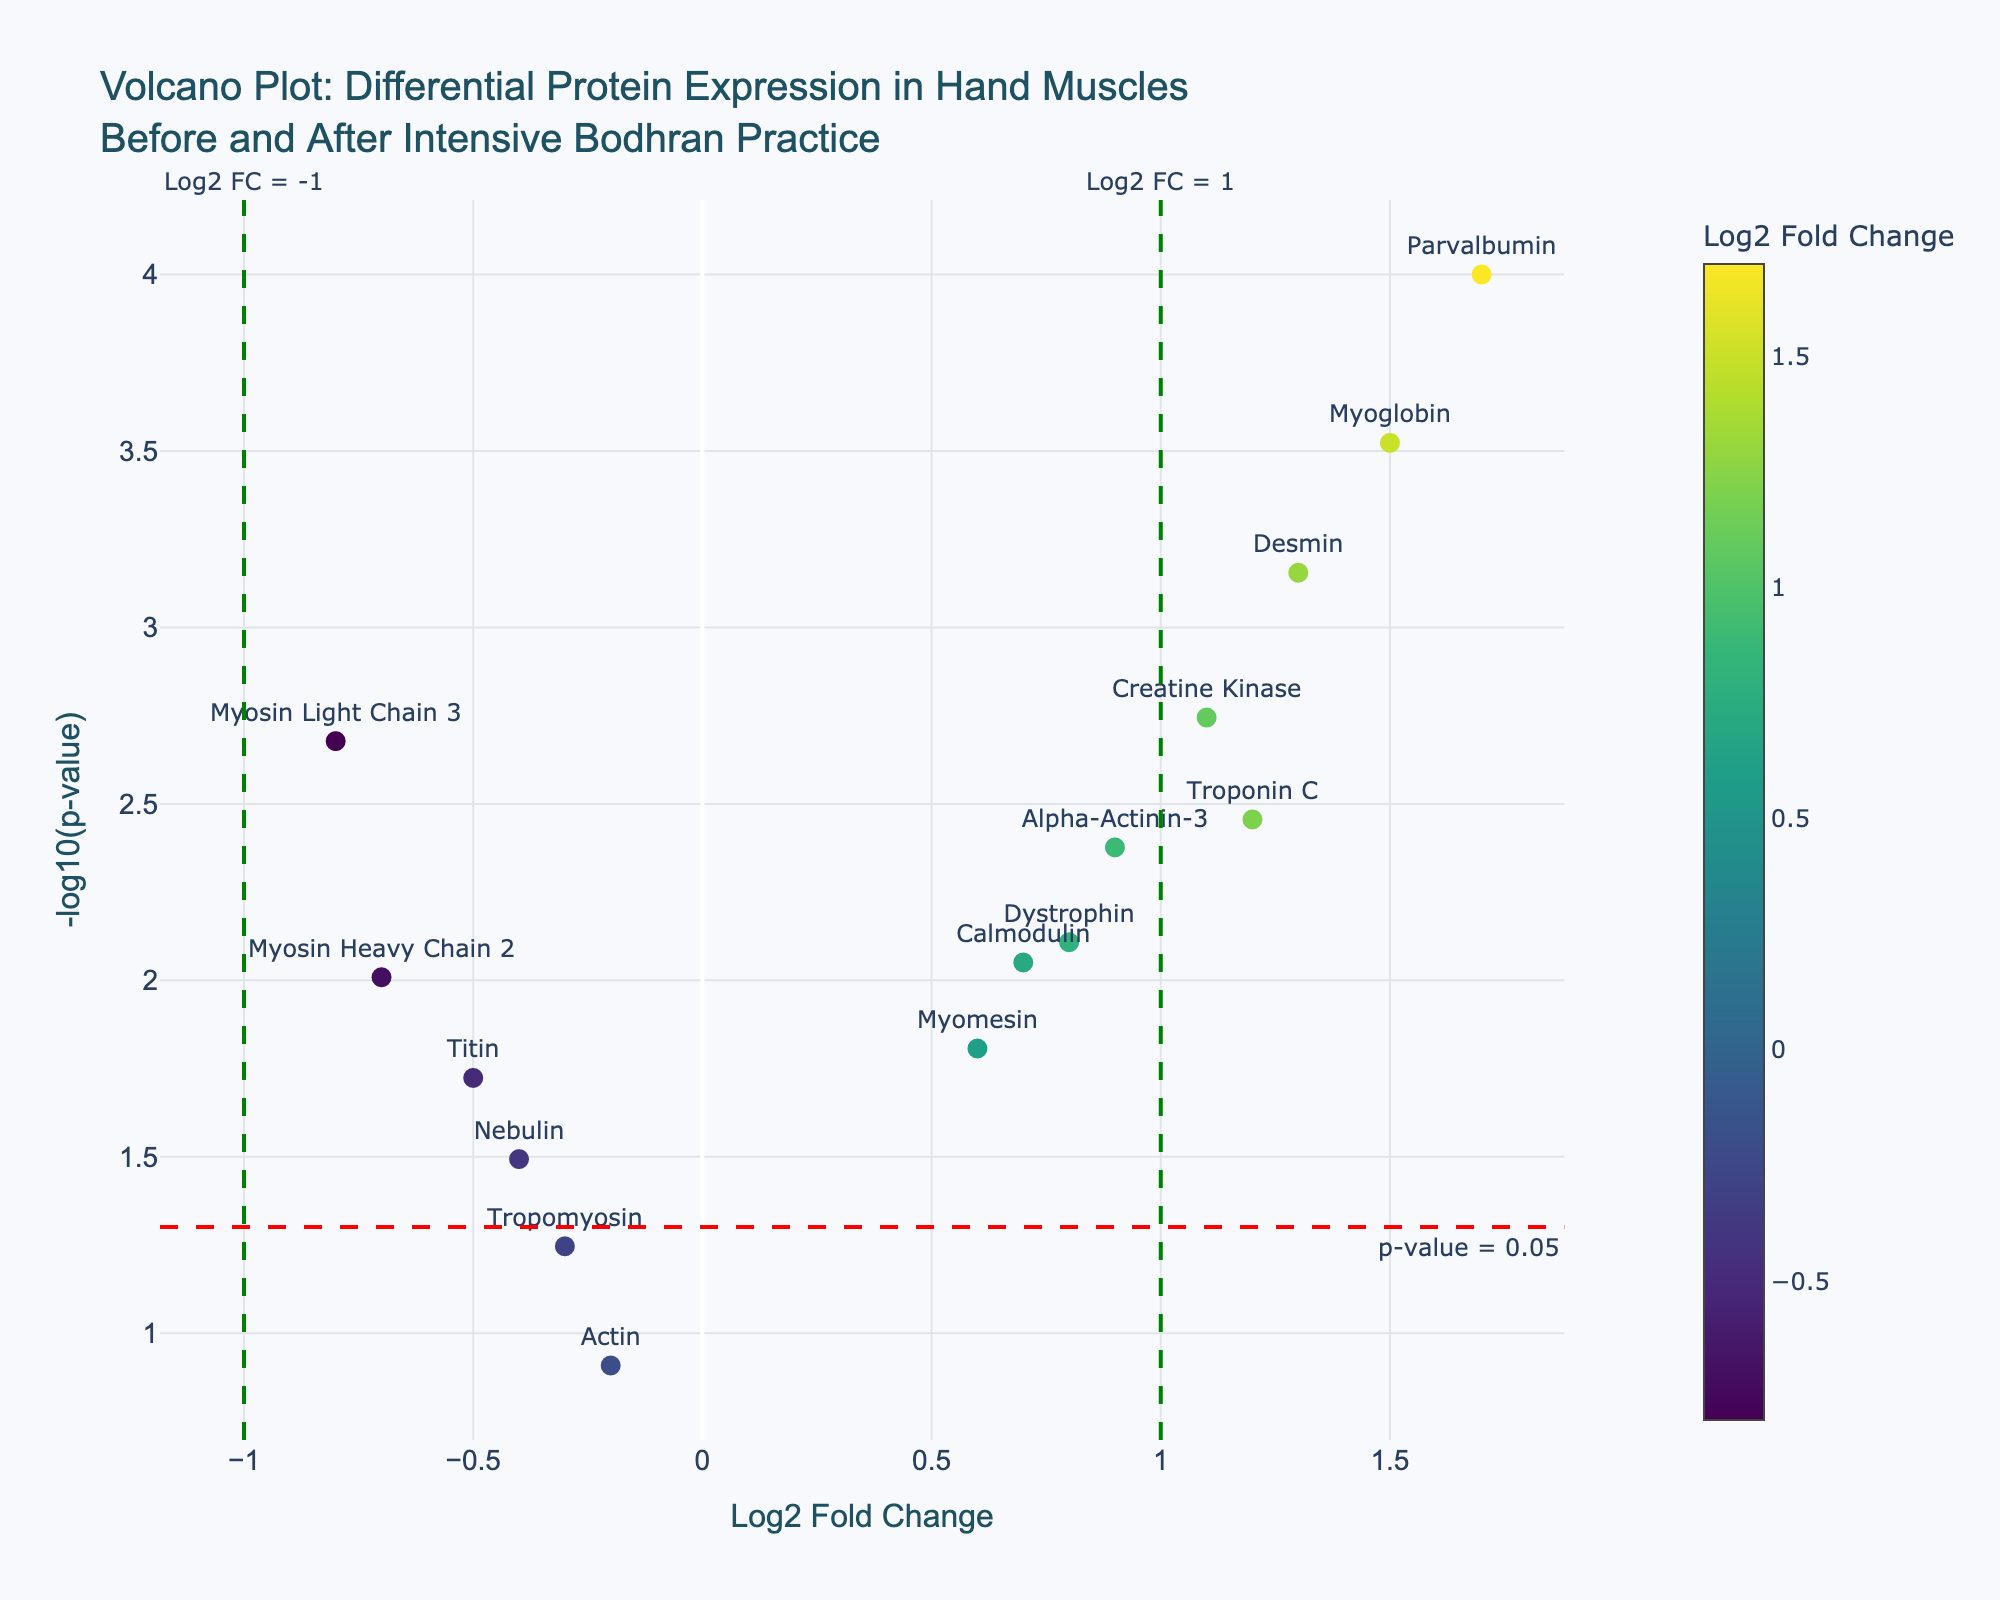What is the title of the plot? The title of the plot is usually displayed at the top and often summarizes what the graph is about. In this case, it says, "Volcano Plot: Differential Protein Expression in Hand Muscles Before and After Intensive Bodhran Practice."
Answer: Volcano Plot: Differential Protein Expression in Hand Muscles Before and After Intensive Bodhran Practice What are the ranges of the X and Y axes? The X-axis ranges from -1.0 to 1.5, representing the Log2 Fold Change. While the exact Y-axis range isn't numeric in the explanation, it would typically accommodate the values of -log10(p-value) shown in the data, and should approximately range from 0 to slightly above 3.
Answer: X-axis: -1.0 to 1.5, Y-axis: 0 to slightly above 3 How many proteins have a Log2 Fold Change greater than 1? To answer this, identify the points on the plot with Log2 Fold Change greater than 1. Based on the data, these are Troponin C, Myoglobin, Desmin, and Parvalbumin, making a total of four proteins.
Answer: 4 Which protein has the highest -log10(p-value) and what is its Log2 Fold Change? Find the point with the highest value on the Y-axis (-log10(p-value)). Parvalbumin has the highest -log10(p-value) (greater than 3) and its Log2 Fold Change is 1.7.
Answer: Parvalbumin, 1.7 How many proteins show statistically significant changes at p-value < 0.05? Any protein with a p-value less than 0.05 will be above the red horizontal line at -log10(0.05), which is enough to identify. This results in Myosin Light Chain 3, Troponin C, Alpha-Actinin-3, Titin, Myoglobin, Creatine Kinase, Calmodulin, Desmin, Myomesin, Nebulin, Dystrophin, Parvalbumin, and Myosin Heavy Chain 2. Thus, there are 13 proteins.
Answer: 13 What colors and sizes are used to represent the data points? The points on the plot are colored using a gradient (likely Viridis color scale) based on the Log2 Fold Change values, and all have roughly similar sizes. Hovering over the color indicates the data's color bar, usually yellow to purple in the scale reference.
Answer: Gradient color with size 10 Which proteins have a negative Log2 Fold Change? Look for points to the left of 0 on the X-axis. These based on data appear to be Myosin Light Chain 3, Titin, Tropomyosin, Actin, Nebulin, and Myosin Heavy Chain 2.
Answer: 6 What is the annotation text at y = -log10(0.05)? Annotations in a plot are often used to highlight important areas; here the horizontal line indicates statistical significance at p-value 0.05. The annotation says "p-value = 0.05".
Answer: p-value = 0.05 